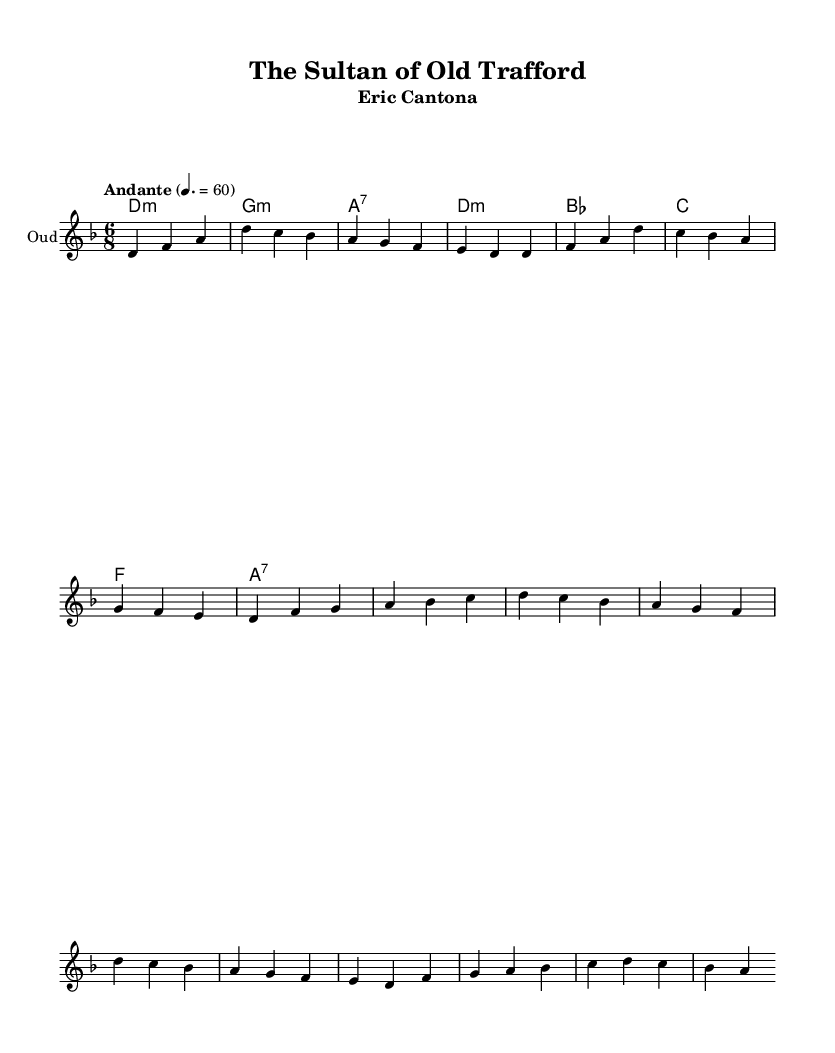What is the key signature of this music? The key signature is D minor, which is indicated by one flat (B flat). This can be identified in the global section under the `\key` command.
Answer: D minor What is the time signature of this music? The time signature is 6/8, which is indicated in the global section under the `\time` command. It signifies that there are six eighth notes per measure.
Answer: 6/8 What is the tempo marking of this piece? The tempo marking is "Andante" with a metronome marking of 60 beats per minute. This indicates a moderately slow tempo. The tempo is specified in the global section.
Answer: Andante, 60 How many measures does the melody contain before the chorus? The melody shows 10 measures for the intro and verse combined before starting the chorus section. By counting the measure bars in the provided melody section, we can affirm this.
Answer: 10 What instrument is specified for the melody? The instrument specified for the melody is the Oud, which is typical for Middle Eastern-influenced music, as indicated in the staff settings.
Answer: Oud What is the first lyric of the verse? The first lyric of the verse is "From Marseille," which can be identified in the lyrics section corresponding to the melody.
Answer: From Marseille Which legendary player is commemorated in this ballad? The ballad commemorates Eric Cantona, as indicated in the title of the score. This is notable as Cantona is a legendary figure for Manchester United supporters.
Answer: Eric Cantona 